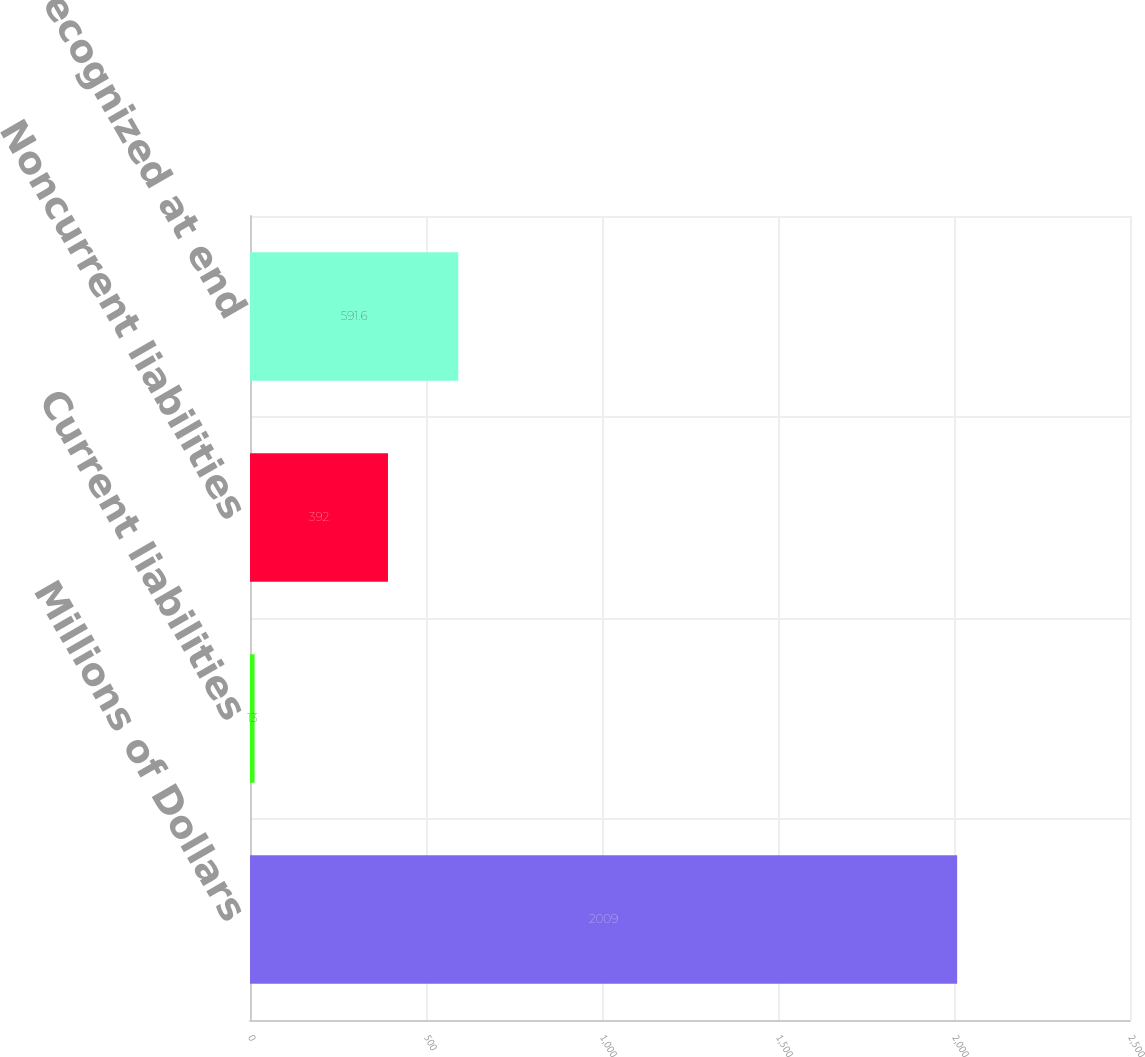Convert chart to OTSL. <chart><loc_0><loc_0><loc_500><loc_500><bar_chart><fcel>Millions of Dollars<fcel>Current liabilities<fcel>Noncurrent liabilities<fcel>Net amounts recognized at end<nl><fcel>2009<fcel>13<fcel>392<fcel>591.6<nl></chart> 